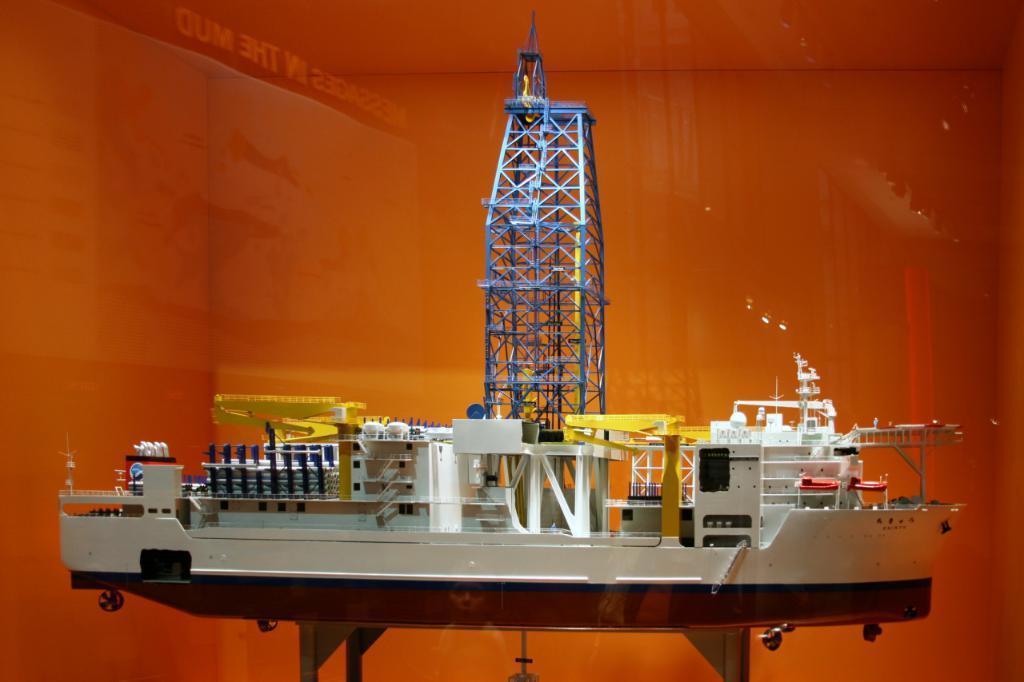Can you describe this image briefly? In the image there is a table with a model of a ship with pole, stairs, pillars and many other objects in it. Behind that model there is a glass with reflection of few objects on it.  